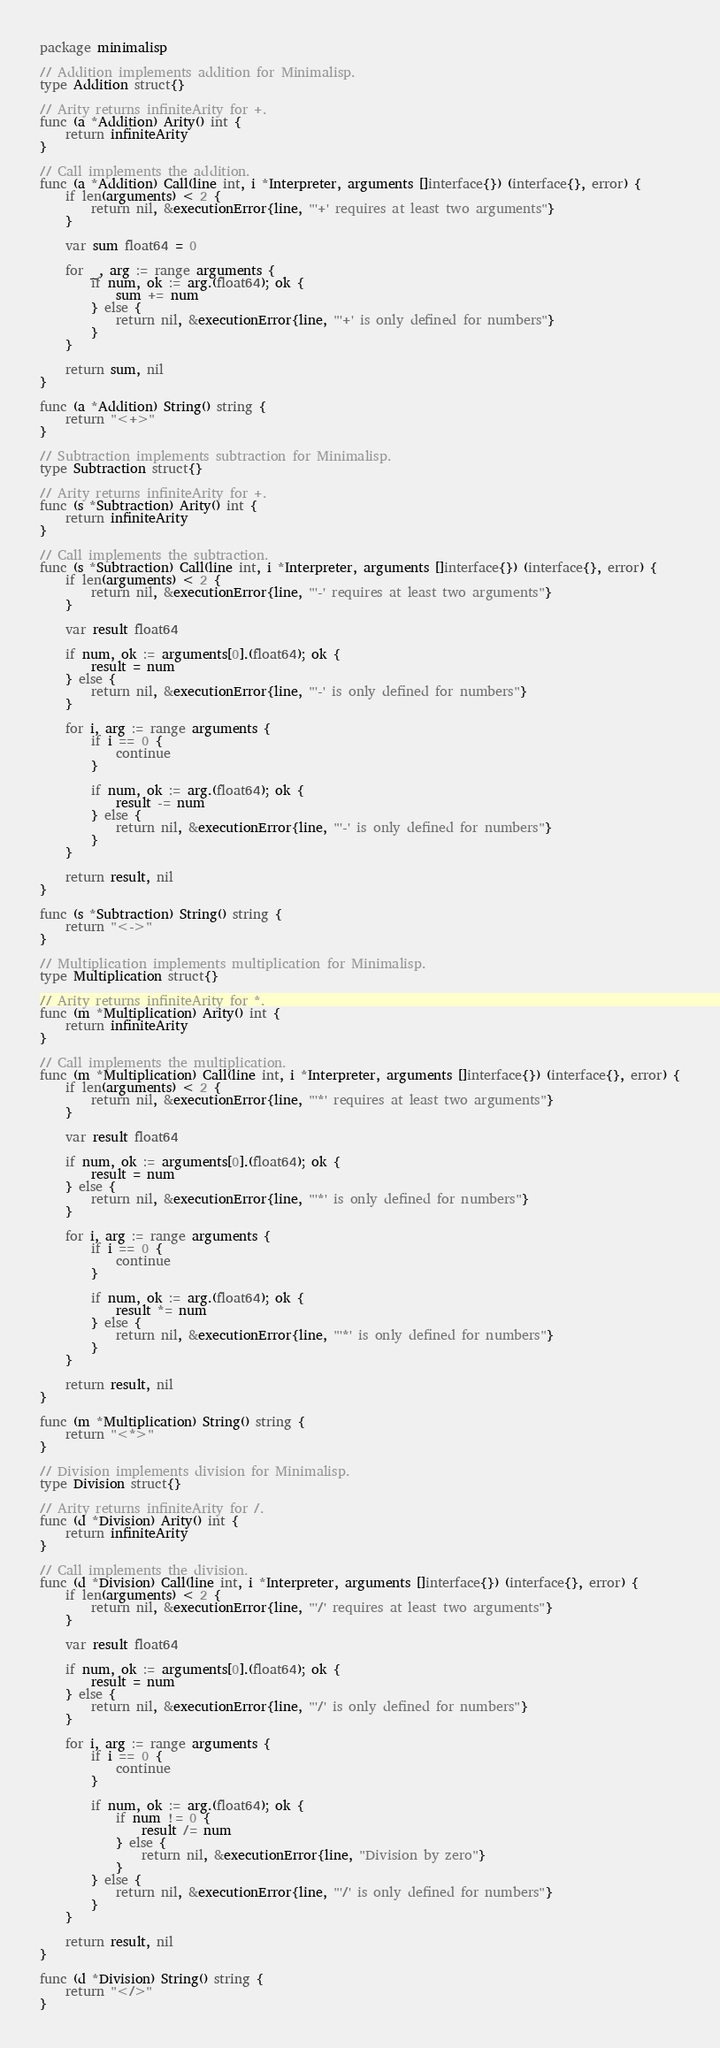Convert code to text. <code><loc_0><loc_0><loc_500><loc_500><_Go_>package minimalisp

// Addition implements addition for Minimalisp.
type Addition struct{}

// Arity returns infiniteArity for +.
func (a *Addition) Arity() int {
	return infiniteArity
}

// Call implements the addition.
func (a *Addition) Call(line int, i *Interpreter, arguments []interface{}) (interface{}, error) {
	if len(arguments) < 2 {
		return nil, &executionError{line, "'+' requires at least two arguments"}
	}

	var sum float64 = 0

	for _, arg := range arguments {
		if num, ok := arg.(float64); ok {
			sum += num
		} else {
			return nil, &executionError{line, "'+' is only defined for numbers"}
		}
	}

	return sum, nil
}

func (a *Addition) String() string {
	return "<+>"
}

// Subtraction implements subtraction for Minimalisp.
type Subtraction struct{}

// Arity returns infiniteArity for +.
func (s *Subtraction) Arity() int {
	return infiniteArity
}

// Call implements the subtraction.
func (s *Subtraction) Call(line int, i *Interpreter, arguments []interface{}) (interface{}, error) {
	if len(arguments) < 2 {
		return nil, &executionError{line, "'-' requires at least two arguments"}
	}

	var result float64

	if num, ok := arguments[0].(float64); ok {
		result = num
	} else {
		return nil, &executionError{line, "'-' is only defined for numbers"}
	}

	for i, arg := range arguments {
		if i == 0 {
			continue
		}

		if num, ok := arg.(float64); ok {
			result -= num
		} else {
			return nil, &executionError{line, "'-' is only defined for numbers"}
		}
	}

	return result, nil
}

func (s *Subtraction) String() string {
	return "<->"
}

// Multiplication implements multiplication for Minimalisp.
type Multiplication struct{}

// Arity returns infiniteArity for *.
func (m *Multiplication) Arity() int {
	return infiniteArity
}

// Call implements the multiplication.
func (m *Multiplication) Call(line int, i *Interpreter, arguments []interface{}) (interface{}, error) {
	if len(arguments) < 2 {
		return nil, &executionError{line, "'*' requires at least two arguments"}
	}

	var result float64

	if num, ok := arguments[0].(float64); ok {
		result = num
	} else {
		return nil, &executionError{line, "'*' is only defined for numbers"}
	}

	for i, arg := range arguments {
		if i == 0 {
			continue
		}

		if num, ok := arg.(float64); ok {
			result *= num
		} else {
			return nil, &executionError{line, "'*' is only defined for numbers"}
		}
	}

	return result, nil
}

func (m *Multiplication) String() string {
	return "<*>"
}

// Division implements division for Minimalisp.
type Division struct{}

// Arity returns infiniteArity for /.
func (d *Division) Arity() int {
	return infiniteArity
}

// Call implements the division.
func (d *Division) Call(line int, i *Interpreter, arguments []interface{}) (interface{}, error) {
	if len(arguments) < 2 {
		return nil, &executionError{line, "'/' requires at least two arguments"}
	}

	var result float64

	if num, ok := arguments[0].(float64); ok {
		result = num
	} else {
		return nil, &executionError{line, "'/' is only defined for numbers"}
	}

	for i, arg := range arguments {
		if i == 0 {
			continue
		}

		if num, ok := arg.(float64); ok {
			if num != 0 {
				result /= num
			} else {
				return nil, &executionError{line, "Division by zero"}
			}
		} else {
			return nil, &executionError{line, "'/' is only defined for numbers"}
		}
	}

	return result, nil
}

func (d *Division) String() string {
	return "</>"
}
</code> 